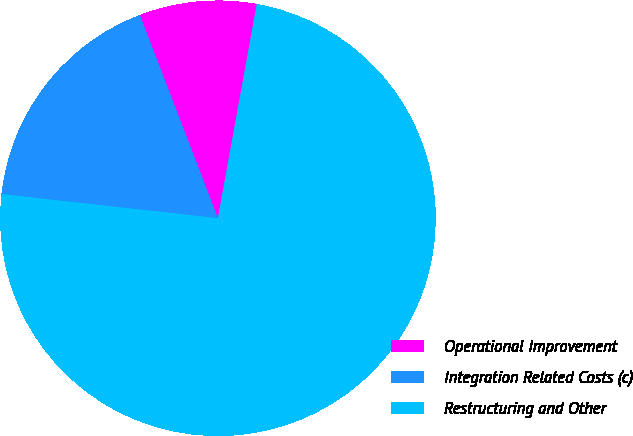Convert chart. <chart><loc_0><loc_0><loc_500><loc_500><pie_chart><fcel>Operational Improvement<fcel>Integration Related Costs (c)<fcel>Restructuring and Other<nl><fcel>8.7%<fcel>17.39%<fcel>73.91%<nl></chart> 